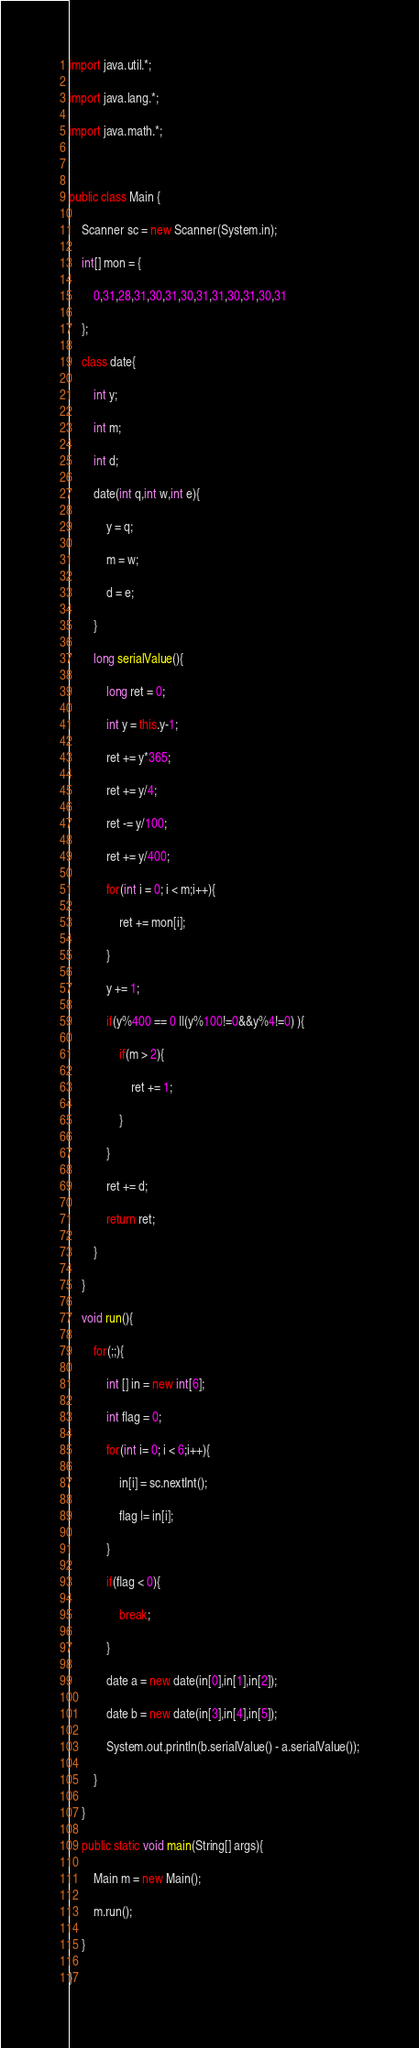Convert code to text. <code><loc_0><loc_0><loc_500><loc_500><_Java_>import java.util.*;

import java.lang.*;

import java.math.*;



public class Main {

	Scanner sc = new Scanner(System.in);

	int[] mon = {

		0,31,28,31,30,31,30,31,31,30,31,30,31	

	};

	class date{

		int y;

		int m;

		int d;

		date(int q,int w,int e){

			y = q;

			m = w;

			d = e;

		}

		long serialValue(){

			long ret = 0;

			int y = this.y-1;

			ret += y*365;

			ret += y/4;

			ret -= y/100;

			ret += y/400;

			for(int i = 0; i < m;i++){

				ret += mon[i];

			}

			y += 1;

			if(y%400 == 0 ||(y%100!=0&&y%4!=0) ){

				if(m > 2){

					ret += 1;

				}

			}

			ret += d;

			return ret;

		}

	}

	void run(){

		for(;;){

			int [] in = new int[6];

			int flag = 0;

			for(int i= 0; i < 6;i++){

				in[i] = sc.nextInt();

				flag |= in[i];

			}

			if(flag < 0){

				break;

			}

			date a = new date(in[0],in[1],in[2]);

			date b = new date(in[3],in[4],in[5]);

			System.out.println(b.serialValue() - a.serialValue());

		}

	}

	public static void main(String[] args){

		Main m = new Main();

		m.run();

	}

}</code> 